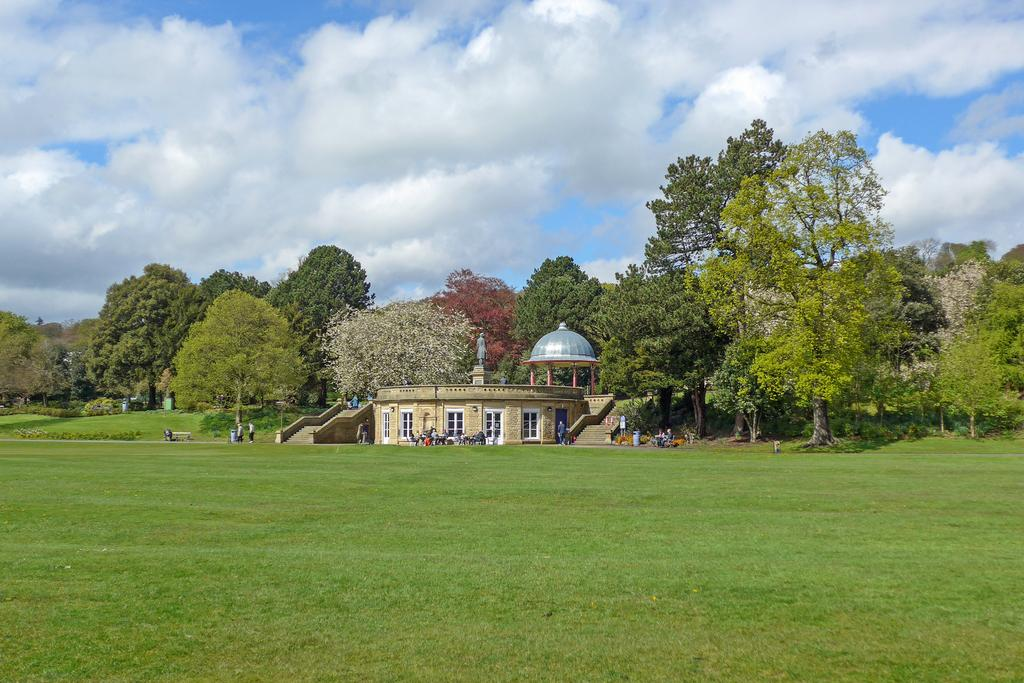Who or what is present in the image? There are people in the image. What type of structure can be seen in the image? There is a house in the image. What is the artistic or historical object in the image? There is a statue in the image. What type of vegetation is present in the image? There are plants, trees, and grass in the image. What is the weather like in the image? The sky is cloudy in the image. How many bears can be seen interacting with the people in the image? There are no bears present in the image; it features people, a house, a statue, plants, trees, grass, and a cloudy sky. What is the limit of the road visible in the image? There is no road present in the image. 